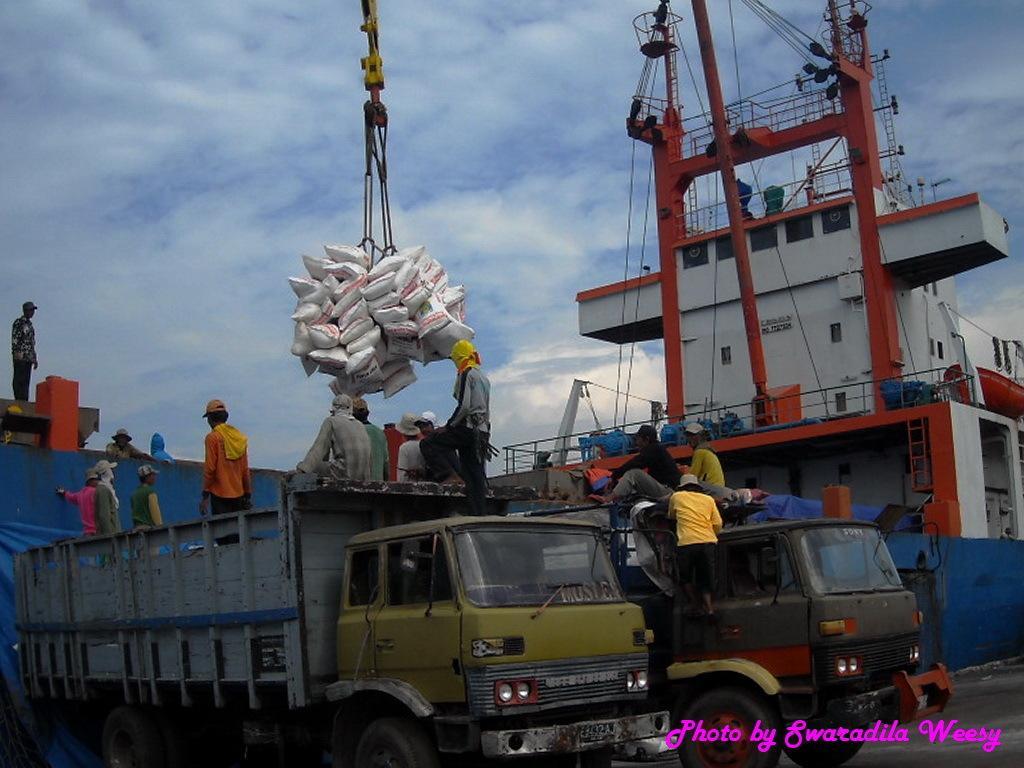In one or two sentences, can you explain what this image depicts? This is an outside view. On the right side there is a ship. At the bottom there two trucks. On the tracks, I can see few people. At the top there is a crane carrying some bags. At the top of the image I can see the sky and clouds. 